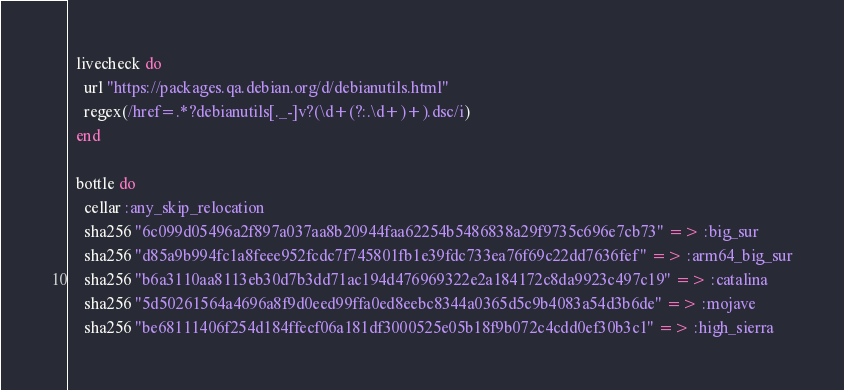Convert code to text. <code><loc_0><loc_0><loc_500><loc_500><_Ruby_>
  livecheck do
    url "https://packages.qa.debian.org/d/debianutils.html"
    regex(/href=.*?debianutils[._-]v?(\d+(?:.\d+)+).dsc/i)
  end

  bottle do
    cellar :any_skip_relocation
    sha256 "6c099d05496a2f897a037aa8b20944faa62254b5486838a29f9735c696e7cb73" => :big_sur
    sha256 "d85a9b994fc1a8feee952fcdc7f745801fb1e39fdc733ea76f69c22dd7636fef" => :arm64_big_sur
    sha256 "b6a3110aa8113eb30d7b3dd71ac194d476969322e2a184172c8da9923c497c19" => :catalina
    sha256 "5d50261564a4696a8f9d0eed99ffa0ed8eebc8344a0365d5c9b4083a54d3b6de" => :mojave
    sha256 "be68111406f254d184ffecf06a181df3000525e05b18f9b072c4cdd0ef30b3c1" => :high_sierra</code> 